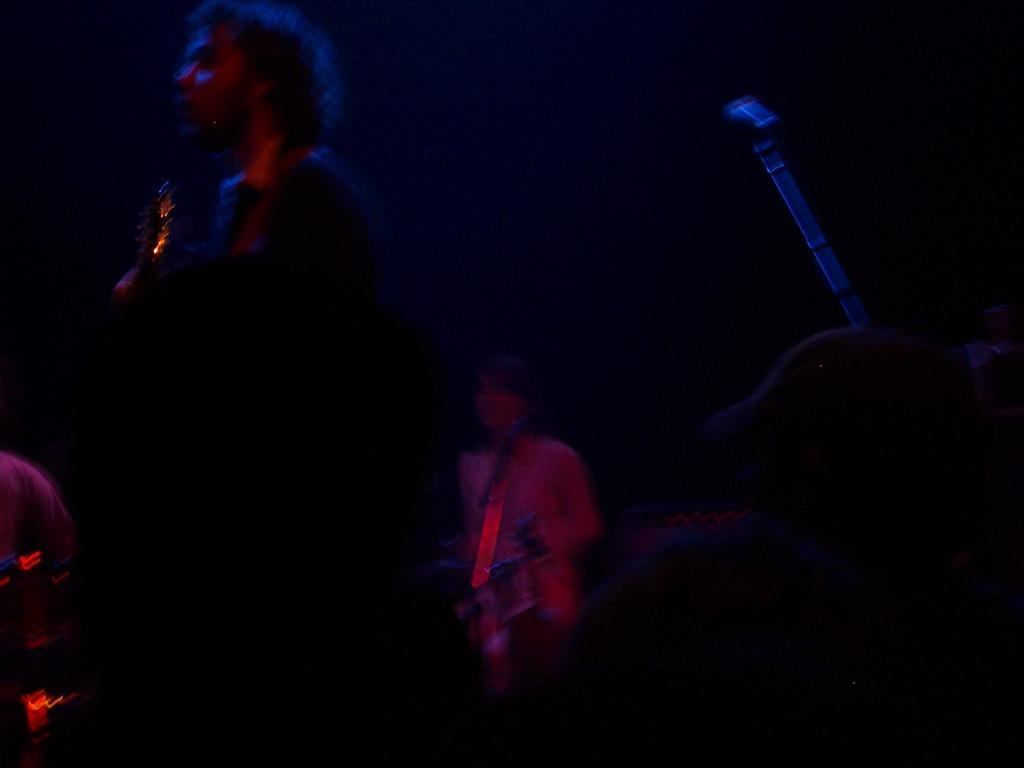How many people are in the image? There are people in the image, but the exact number is not specified. What are the people doing in the image? The people are standing in the image. Can you describe any specific objects or items held by the people? One person is holding a guitar, and there are other musical instruments in the image. What type of alarm can be heard going off in the image? There is no alarm present in the image, and therefore no sound can be heard. 